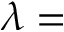<formula> <loc_0><loc_0><loc_500><loc_500>\lambda =</formula> 